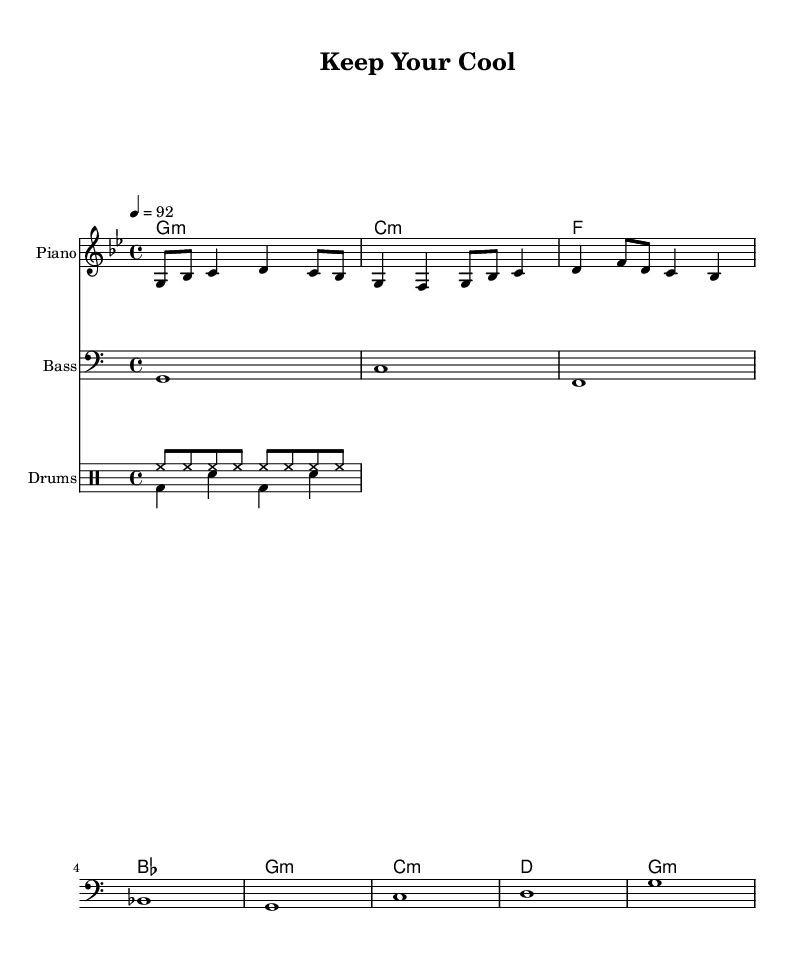What is the key signature of this music? The key signature is G minor, which has two flats (B♭ and E♭).
Answer: G minor What is the time signature for this piece? The time signature is indicated as 4/4, meaning there are four beats in each measure and the quarter note gets one beat.
Answer: 4/4 What is the tempo marking for this rap piece? The tempo marking is 92 beats per minute, indicated by the "4 = 92" which means the quarter note should be played at this speed.
Answer: 92 How many measures are in the provided melody? The melody consists of two measures. Each measure is separated by a vertical line, and there are two clear groups of notes.
Answer: 2 What instruments are used in this composition? The composition includes piano, bass, and drums, as denoted by the instrument names labeled above the respective staves.
Answer: Piano, Bass, Drums What is the rhythmic structure of the drum pattern? The drum pattern consists of a steady hi-hat rhythm in eighth notes and a bass-drum/snare alternation, providing an upbeat tempo characteristic of hip-hop.
Answer: Hi-hat and Bass-Snare 